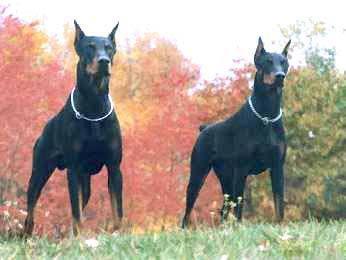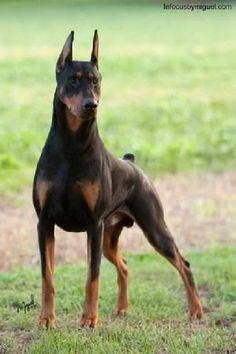The first image is the image on the left, the second image is the image on the right. Analyze the images presented: Is the assertion "At least one dog has its mouth open in one picture and none do in the other." valid? Answer yes or no. No. The first image is the image on the left, the second image is the image on the right. Examine the images to the left and right. Is the description "One image contains two dobermans sitting upright side-by side, and the other image features two dobermans reclining side-by-side." accurate? Answer yes or no. No. 